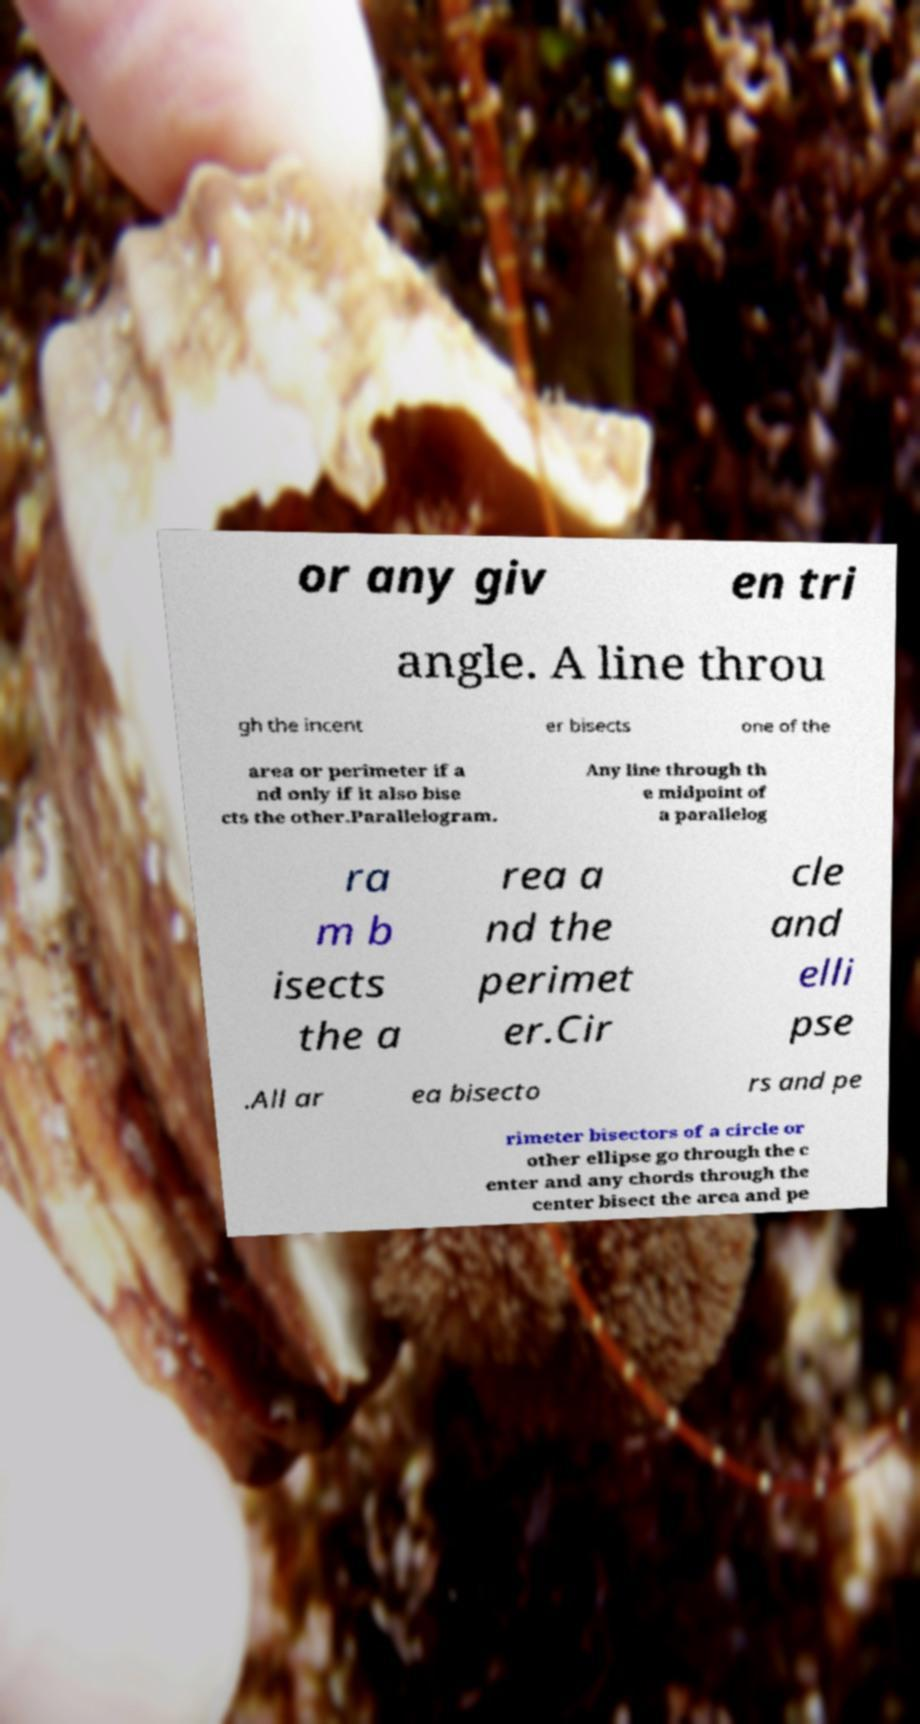For documentation purposes, I need the text within this image transcribed. Could you provide that? or any giv en tri angle. A line throu gh the incent er bisects one of the area or perimeter if a nd only if it also bise cts the other.Parallelogram. Any line through th e midpoint of a parallelog ra m b isects the a rea a nd the perimet er.Cir cle and elli pse .All ar ea bisecto rs and pe rimeter bisectors of a circle or other ellipse go through the c enter and any chords through the center bisect the area and pe 